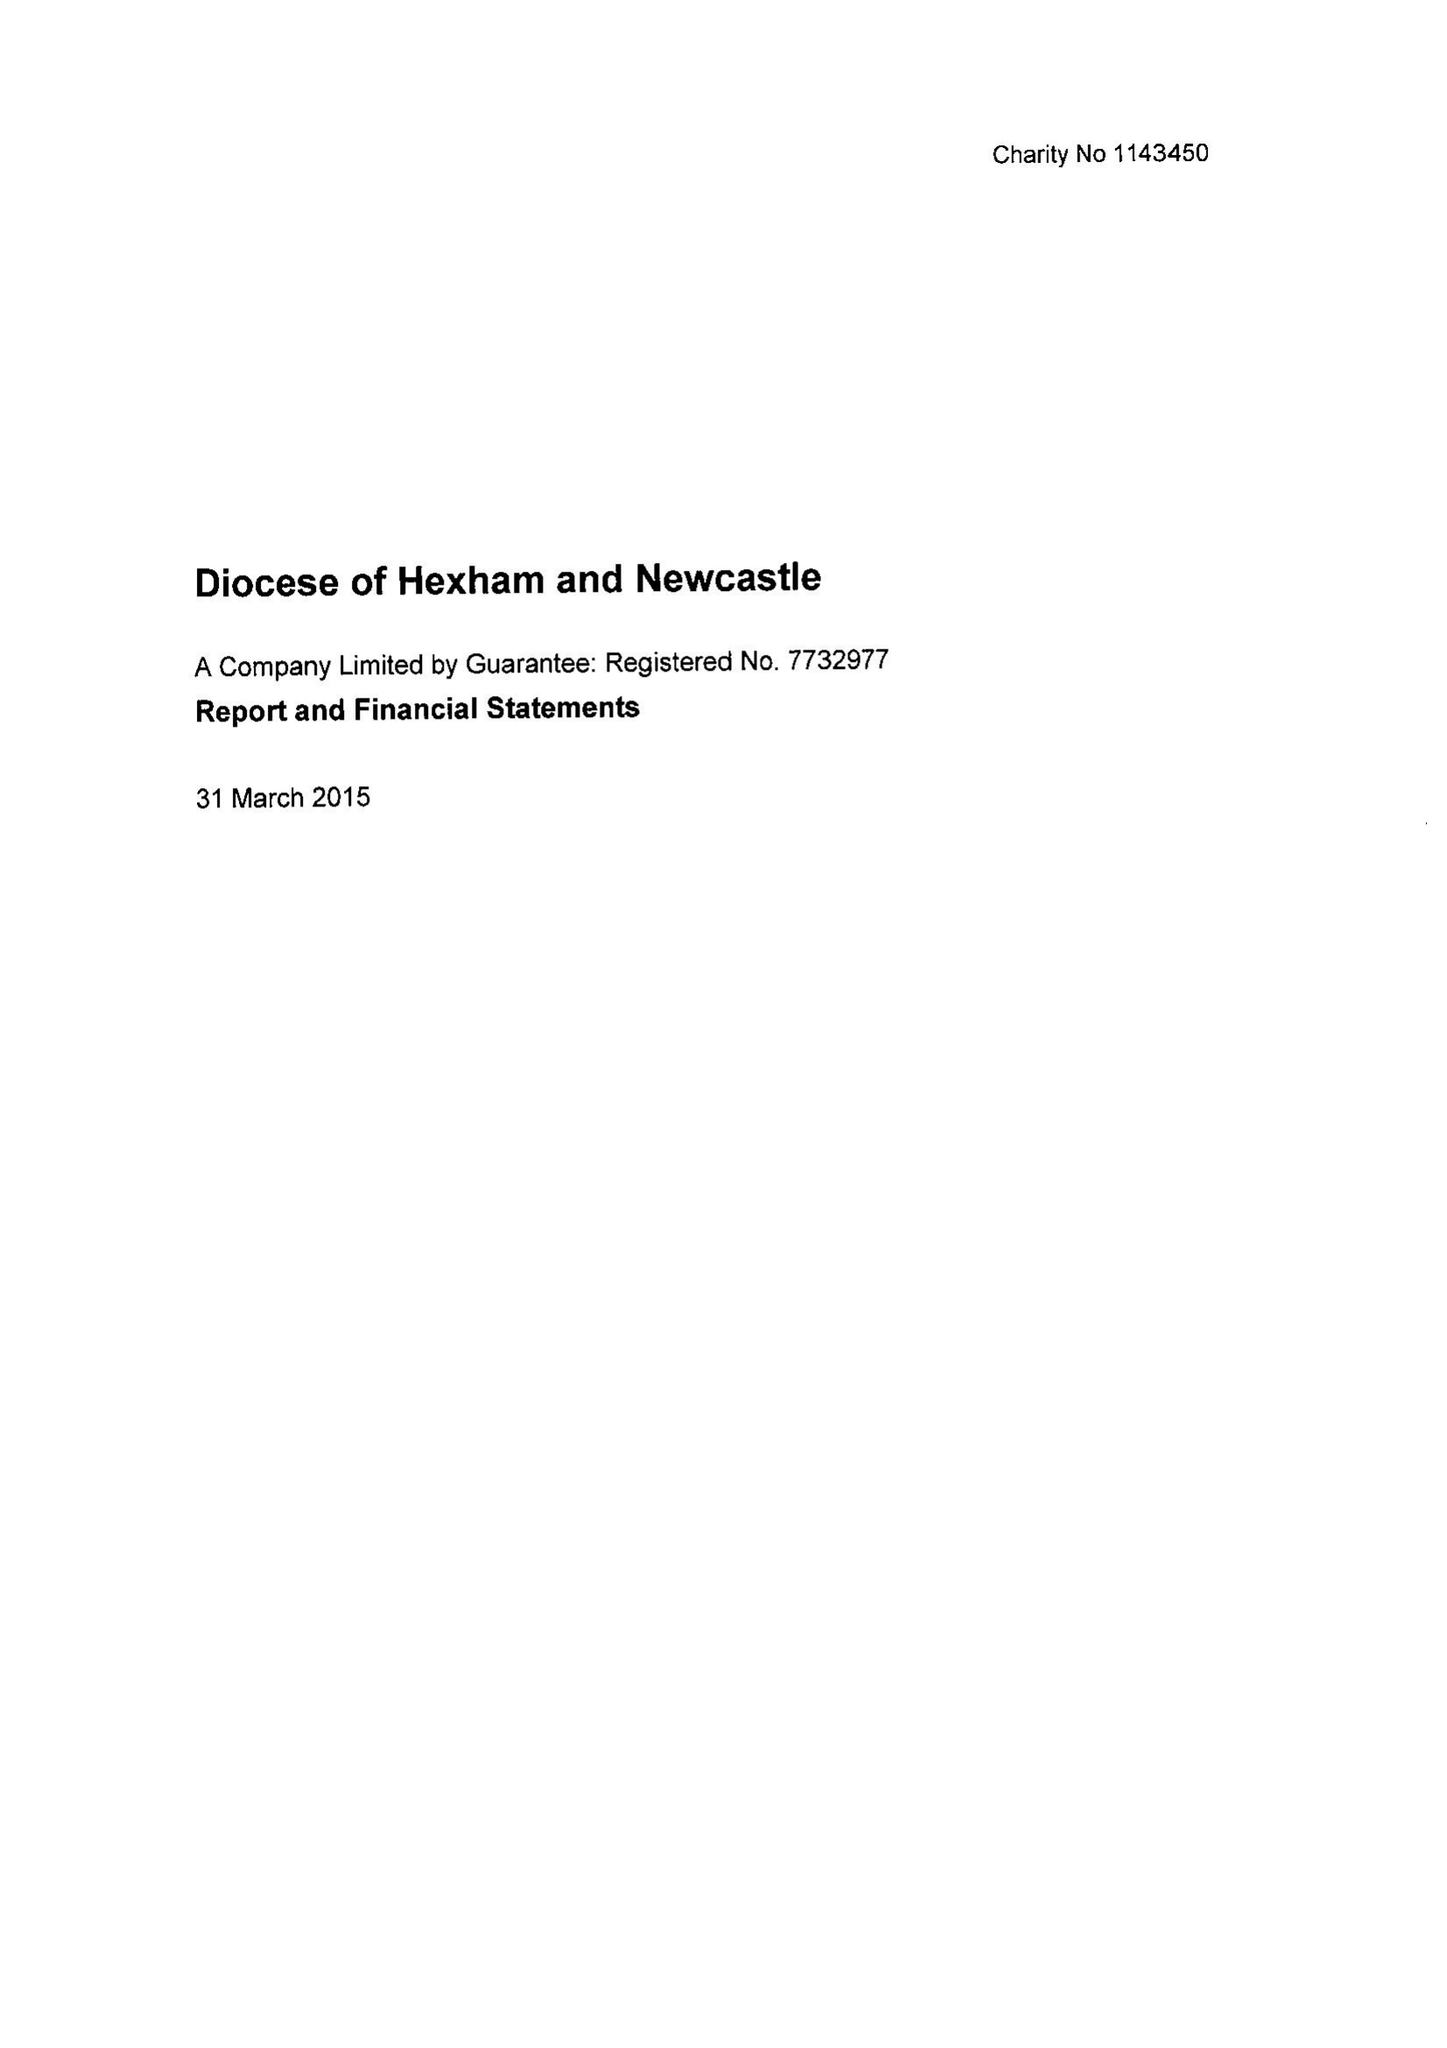What is the value for the income_annually_in_british_pounds?
Answer the question using a single word or phrase. 22192172.00 